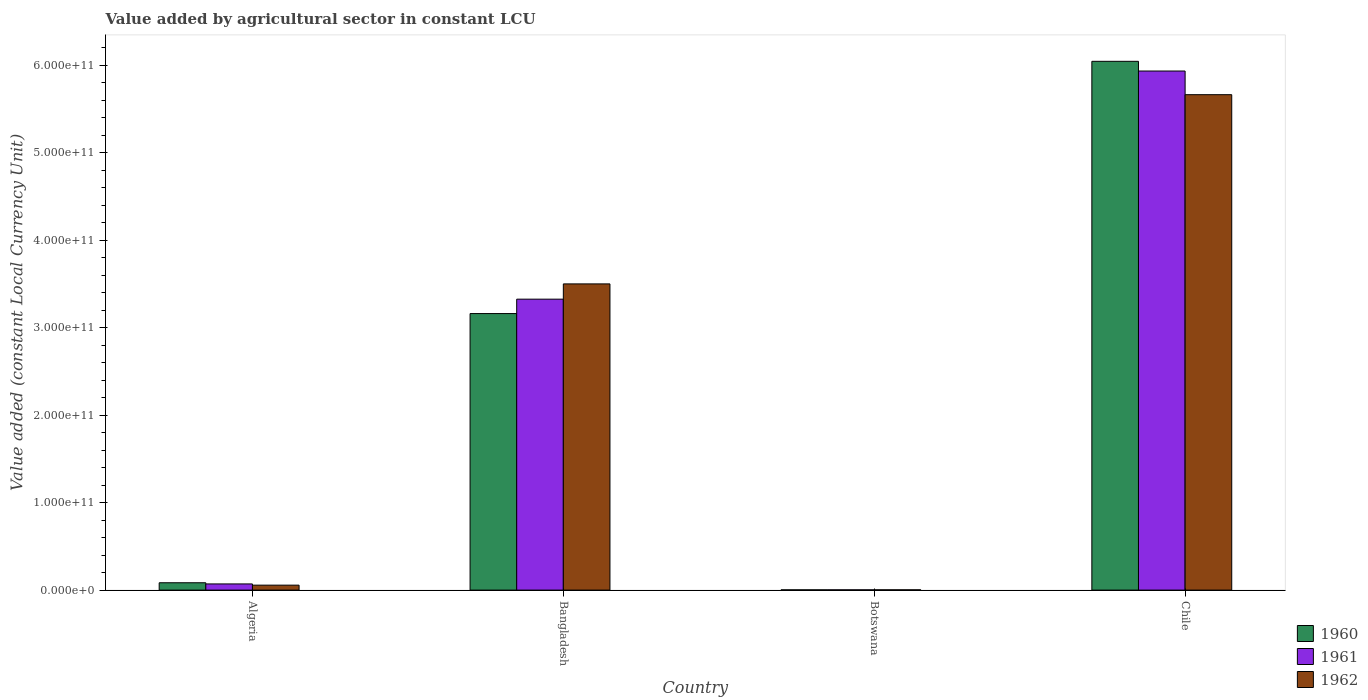How many different coloured bars are there?
Offer a terse response. 3. How many bars are there on the 4th tick from the right?
Offer a very short reply. 3. What is the label of the 3rd group of bars from the left?
Ensure brevity in your answer.  Botswana. What is the value added by agricultural sector in 1962 in Algeria?
Make the answer very short. 5.66e+09. Across all countries, what is the maximum value added by agricultural sector in 1961?
Offer a very short reply. 5.94e+11. Across all countries, what is the minimum value added by agricultural sector in 1960?
Your answer should be compact. 2.79e+08. In which country was the value added by agricultural sector in 1961 maximum?
Keep it short and to the point. Chile. In which country was the value added by agricultural sector in 1961 minimum?
Offer a very short reply. Botswana. What is the total value added by agricultural sector in 1962 in the graph?
Offer a very short reply. 9.23e+11. What is the difference between the value added by agricultural sector in 1960 in Botswana and that in Chile?
Provide a short and direct response. -6.04e+11. What is the difference between the value added by agricultural sector in 1961 in Chile and the value added by agricultural sector in 1962 in Bangladesh?
Give a very brief answer. 2.43e+11. What is the average value added by agricultural sector in 1962 per country?
Your answer should be compact. 2.31e+11. What is the difference between the value added by agricultural sector of/in 1960 and value added by agricultural sector of/in 1962 in Chile?
Your response must be concise. 3.82e+1. What is the ratio of the value added by agricultural sector in 1962 in Bangladesh to that in Chile?
Your response must be concise. 0.62. Is the difference between the value added by agricultural sector in 1960 in Botswana and Chile greater than the difference between the value added by agricultural sector in 1962 in Botswana and Chile?
Offer a terse response. No. What is the difference between the highest and the second highest value added by agricultural sector in 1961?
Offer a very short reply. 5.87e+11. What is the difference between the highest and the lowest value added by agricultural sector in 1960?
Your response must be concise. 6.04e+11. In how many countries, is the value added by agricultural sector in 1962 greater than the average value added by agricultural sector in 1962 taken over all countries?
Ensure brevity in your answer.  2. Is it the case that in every country, the sum of the value added by agricultural sector in 1960 and value added by agricultural sector in 1961 is greater than the value added by agricultural sector in 1962?
Give a very brief answer. Yes. Are all the bars in the graph horizontal?
Ensure brevity in your answer.  No. How many countries are there in the graph?
Provide a succinct answer. 4. What is the difference between two consecutive major ticks on the Y-axis?
Ensure brevity in your answer.  1.00e+11. Are the values on the major ticks of Y-axis written in scientific E-notation?
Your answer should be very brief. Yes. Does the graph contain grids?
Offer a terse response. No. How many legend labels are there?
Provide a short and direct response. 3. What is the title of the graph?
Your answer should be compact. Value added by agricultural sector in constant LCU. Does "1986" appear as one of the legend labels in the graph?
Provide a succinct answer. No. What is the label or title of the Y-axis?
Provide a succinct answer. Value added (constant Local Currency Unit). What is the Value added (constant Local Currency Unit) in 1960 in Algeria?
Offer a terse response. 8.40e+09. What is the Value added (constant Local Currency Unit) of 1961 in Algeria?
Give a very brief answer. 7.05e+09. What is the Value added (constant Local Currency Unit) in 1962 in Algeria?
Make the answer very short. 5.66e+09. What is the Value added (constant Local Currency Unit) in 1960 in Bangladesh?
Provide a short and direct response. 3.16e+11. What is the Value added (constant Local Currency Unit) in 1961 in Bangladesh?
Your response must be concise. 3.33e+11. What is the Value added (constant Local Currency Unit) of 1962 in Bangladesh?
Your answer should be very brief. 3.50e+11. What is the Value added (constant Local Currency Unit) of 1960 in Botswana?
Provide a short and direct response. 2.79e+08. What is the Value added (constant Local Currency Unit) of 1961 in Botswana?
Your answer should be very brief. 2.86e+08. What is the Value added (constant Local Currency Unit) in 1962 in Botswana?
Ensure brevity in your answer.  2.96e+08. What is the Value added (constant Local Currency Unit) of 1960 in Chile?
Provide a short and direct response. 6.05e+11. What is the Value added (constant Local Currency Unit) in 1961 in Chile?
Give a very brief answer. 5.94e+11. What is the Value added (constant Local Currency Unit) of 1962 in Chile?
Offer a terse response. 5.67e+11. Across all countries, what is the maximum Value added (constant Local Currency Unit) in 1960?
Your response must be concise. 6.05e+11. Across all countries, what is the maximum Value added (constant Local Currency Unit) in 1961?
Keep it short and to the point. 5.94e+11. Across all countries, what is the maximum Value added (constant Local Currency Unit) of 1962?
Your answer should be very brief. 5.67e+11. Across all countries, what is the minimum Value added (constant Local Currency Unit) of 1960?
Provide a succinct answer. 2.79e+08. Across all countries, what is the minimum Value added (constant Local Currency Unit) in 1961?
Your answer should be compact. 2.86e+08. Across all countries, what is the minimum Value added (constant Local Currency Unit) of 1962?
Ensure brevity in your answer.  2.96e+08. What is the total Value added (constant Local Currency Unit) of 1960 in the graph?
Provide a short and direct response. 9.30e+11. What is the total Value added (constant Local Currency Unit) in 1961 in the graph?
Your answer should be very brief. 9.34e+11. What is the total Value added (constant Local Currency Unit) in 1962 in the graph?
Your answer should be compact. 9.23e+11. What is the difference between the Value added (constant Local Currency Unit) in 1960 in Algeria and that in Bangladesh?
Make the answer very short. -3.08e+11. What is the difference between the Value added (constant Local Currency Unit) in 1961 in Algeria and that in Bangladesh?
Keep it short and to the point. -3.26e+11. What is the difference between the Value added (constant Local Currency Unit) in 1962 in Algeria and that in Bangladesh?
Provide a succinct answer. -3.44e+11. What is the difference between the Value added (constant Local Currency Unit) of 1960 in Algeria and that in Botswana?
Your answer should be very brief. 8.12e+09. What is the difference between the Value added (constant Local Currency Unit) in 1961 in Algeria and that in Botswana?
Provide a short and direct response. 6.77e+09. What is the difference between the Value added (constant Local Currency Unit) of 1962 in Algeria and that in Botswana?
Keep it short and to the point. 5.36e+09. What is the difference between the Value added (constant Local Currency Unit) of 1960 in Algeria and that in Chile?
Your response must be concise. -5.96e+11. What is the difference between the Value added (constant Local Currency Unit) in 1961 in Algeria and that in Chile?
Offer a very short reply. -5.87e+11. What is the difference between the Value added (constant Local Currency Unit) of 1962 in Algeria and that in Chile?
Make the answer very short. -5.61e+11. What is the difference between the Value added (constant Local Currency Unit) in 1960 in Bangladesh and that in Botswana?
Give a very brief answer. 3.16e+11. What is the difference between the Value added (constant Local Currency Unit) in 1961 in Bangladesh and that in Botswana?
Your answer should be very brief. 3.32e+11. What is the difference between the Value added (constant Local Currency Unit) in 1962 in Bangladesh and that in Botswana?
Give a very brief answer. 3.50e+11. What is the difference between the Value added (constant Local Currency Unit) in 1960 in Bangladesh and that in Chile?
Make the answer very short. -2.88e+11. What is the difference between the Value added (constant Local Currency Unit) of 1961 in Bangladesh and that in Chile?
Provide a succinct answer. -2.61e+11. What is the difference between the Value added (constant Local Currency Unit) in 1962 in Bangladesh and that in Chile?
Provide a short and direct response. -2.16e+11. What is the difference between the Value added (constant Local Currency Unit) of 1960 in Botswana and that in Chile?
Offer a very short reply. -6.04e+11. What is the difference between the Value added (constant Local Currency Unit) of 1961 in Botswana and that in Chile?
Offer a very short reply. -5.93e+11. What is the difference between the Value added (constant Local Currency Unit) of 1962 in Botswana and that in Chile?
Provide a succinct answer. -5.66e+11. What is the difference between the Value added (constant Local Currency Unit) in 1960 in Algeria and the Value added (constant Local Currency Unit) in 1961 in Bangladesh?
Keep it short and to the point. -3.24e+11. What is the difference between the Value added (constant Local Currency Unit) in 1960 in Algeria and the Value added (constant Local Currency Unit) in 1962 in Bangladesh?
Offer a terse response. -3.42e+11. What is the difference between the Value added (constant Local Currency Unit) of 1961 in Algeria and the Value added (constant Local Currency Unit) of 1962 in Bangladesh?
Your response must be concise. -3.43e+11. What is the difference between the Value added (constant Local Currency Unit) of 1960 in Algeria and the Value added (constant Local Currency Unit) of 1961 in Botswana?
Ensure brevity in your answer.  8.11e+09. What is the difference between the Value added (constant Local Currency Unit) of 1960 in Algeria and the Value added (constant Local Currency Unit) of 1962 in Botswana?
Your answer should be very brief. 8.10e+09. What is the difference between the Value added (constant Local Currency Unit) of 1961 in Algeria and the Value added (constant Local Currency Unit) of 1962 in Botswana?
Give a very brief answer. 6.76e+09. What is the difference between the Value added (constant Local Currency Unit) in 1960 in Algeria and the Value added (constant Local Currency Unit) in 1961 in Chile?
Offer a very short reply. -5.85e+11. What is the difference between the Value added (constant Local Currency Unit) in 1960 in Algeria and the Value added (constant Local Currency Unit) in 1962 in Chile?
Ensure brevity in your answer.  -5.58e+11. What is the difference between the Value added (constant Local Currency Unit) in 1961 in Algeria and the Value added (constant Local Currency Unit) in 1962 in Chile?
Give a very brief answer. -5.59e+11. What is the difference between the Value added (constant Local Currency Unit) of 1960 in Bangladesh and the Value added (constant Local Currency Unit) of 1961 in Botswana?
Give a very brief answer. 3.16e+11. What is the difference between the Value added (constant Local Currency Unit) of 1960 in Bangladesh and the Value added (constant Local Currency Unit) of 1962 in Botswana?
Your response must be concise. 3.16e+11. What is the difference between the Value added (constant Local Currency Unit) of 1961 in Bangladesh and the Value added (constant Local Currency Unit) of 1962 in Botswana?
Your response must be concise. 3.32e+11. What is the difference between the Value added (constant Local Currency Unit) of 1960 in Bangladesh and the Value added (constant Local Currency Unit) of 1961 in Chile?
Make the answer very short. -2.77e+11. What is the difference between the Value added (constant Local Currency Unit) of 1960 in Bangladesh and the Value added (constant Local Currency Unit) of 1962 in Chile?
Offer a terse response. -2.50e+11. What is the difference between the Value added (constant Local Currency Unit) in 1961 in Bangladesh and the Value added (constant Local Currency Unit) in 1962 in Chile?
Provide a succinct answer. -2.34e+11. What is the difference between the Value added (constant Local Currency Unit) in 1960 in Botswana and the Value added (constant Local Currency Unit) in 1961 in Chile?
Keep it short and to the point. -5.93e+11. What is the difference between the Value added (constant Local Currency Unit) in 1960 in Botswana and the Value added (constant Local Currency Unit) in 1962 in Chile?
Provide a succinct answer. -5.66e+11. What is the difference between the Value added (constant Local Currency Unit) in 1961 in Botswana and the Value added (constant Local Currency Unit) in 1962 in Chile?
Your answer should be compact. -5.66e+11. What is the average Value added (constant Local Currency Unit) in 1960 per country?
Offer a very short reply. 2.32e+11. What is the average Value added (constant Local Currency Unit) of 1961 per country?
Your response must be concise. 2.33e+11. What is the average Value added (constant Local Currency Unit) in 1962 per country?
Ensure brevity in your answer.  2.31e+11. What is the difference between the Value added (constant Local Currency Unit) in 1960 and Value added (constant Local Currency Unit) in 1961 in Algeria?
Your answer should be very brief. 1.35e+09. What is the difference between the Value added (constant Local Currency Unit) in 1960 and Value added (constant Local Currency Unit) in 1962 in Algeria?
Offer a very short reply. 2.74e+09. What is the difference between the Value added (constant Local Currency Unit) in 1961 and Value added (constant Local Currency Unit) in 1962 in Algeria?
Your answer should be very brief. 1.40e+09. What is the difference between the Value added (constant Local Currency Unit) in 1960 and Value added (constant Local Currency Unit) in 1961 in Bangladesh?
Provide a succinct answer. -1.65e+1. What is the difference between the Value added (constant Local Currency Unit) of 1960 and Value added (constant Local Currency Unit) of 1962 in Bangladesh?
Your answer should be compact. -3.39e+1. What is the difference between the Value added (constant Local Currency Unit) in 1961 and Value added (constant Local Currency Unit) in 1962 in Bangladesh?
Provide a succinct answer. -1.75e+1. What is the difference between the Value added (constant Local Currency Unit) of 1960 and Value added (constant Local Currency Unit) of 1961 in Botswana?
Your answer should be compact. -6.88e+06. What is the difference between the Value added (constant Local Currency Unit) of 1960 and Value added (constant Local Currency Unit) of 1962 in Botswana?
Offer a terse response. -1.72e+07. What is the difference between the Value added (constant Local Currency Unit) in 1961 and Value added (constant Local Currency Unit) in 1962 in Botswana?
Give a very brief answer. -1.03e+07. What is the difference between the Value added (constant Local Currency Unit) in 1960 and Value added (constant Local Currency Unit) in 1961 in Chile?
Keep it short and to the point. 1.11e+1. What is the difference between the Value added (constant Local Currency Unit) of 1960 and Value added (constant Local Currency Unit) of 1962 in Chile?
Give a very brief answer. 3.82e+1. What is the difference between the Value added (constant Local Currency Unit) of 1961 and Value added (constant Local Currency Unit) of 1962 in Chile?
Offer a terse response. 2.70e+1. What is the ratio of the Value added (constant Local Currency Unit) of 1960 in Algeria to that in Bangladesh?
Your answer should be very brief. 0.03. What is the ratio of the Value added (constant Local Currency Unit) in 1961 in Algeria to that in Bangladesh?
Make the answer very short. 0.02. What is the ratio of the Value added (constant Local Currency Unit) of 1962 in Algeria to that in Bangladesh?
Offer a very short reply. 0.02. What is the ratio of the Value added (constant Local Currency Unit) in 1960 in Algeria to that in Botswana?
Keep it short and to the point. 30.08. What is the ratio of the Value added (constant Local Currency Unit) in 1961 in Algeria to that in Botswana?
Offer a very short reply. 24.65. What is the ratio of the Value added (constant Local Currency Unit) of 1962 in Algeria to that in Botswana?
Give a very brief answer. 19.09. What is the ratio of the Value added (constant Local Currency Unit) of 1960 in Algeria to that in Chile?
Your answer should be very brief. 0.01. What is the ratio of the Value added (constant Local Currency Unit) in 1961 in Algeria to that in Chile?
Keep it short and to the point. 0.01. What is the ratio of the Value added (constant Local Currency Unit) in 1962 in Algeria to that in Chile?
Provide a succinct answer. 0.01. What is the ratio of the Value added (constant Local Currency Unit) in 1960 in Bangladesh to that in Botswana?
Ensure brevity in your answer.  1132.8. What is the ratio of the Value added (constant Local Currency Unit) in 1961 in Bangladesh to that in Botswana?
Offer a terse response. 1163.15. What is the ratio of the Value added (constant Local Currency Unit) in 1962 in Bangladesh to that in Botswana?
Offer a terse response. 1181.56. What is the ratio of the Value added (constant Local Currency Unit) in 1960 in Bangladesh to that in Chile?
Your answer should be compact. 0.52. What is the ratio of the Value added (constant Local Currency Unit) of 1961 in Bangladesh to that in Chile?
Your answer should be compact. 0.56. What is the ratio of the Value added (constant Local Currency Unit) of 1962 in Bangladesh to that in Chile?
Give a very brief answer. 0.62. What is the ratio of the Value added (constant Local Currency Unit) in 1960 in Botswana to that in Chile?
Provide a succinct answer. 0. What is the difference between the highest and the second highest Value added (constant Local Currency Unit) in 1960?
Keep it short and to the point. 2.88e+11. What is the difference between the highest and the second highest Value added (constant Local Currency Unit) in 1961?
Offer a terse response. 2.61e+11. What is the difference between the highest and the second highest Value added (constant Local Currency Unit) in 1962?
Provide a short and direct response. 2.16e+11. What is the difference between the highest and the lowest Value added (constant Local Currency Unit) of 1960?
Offer a terse response. 6.04e+11. What is the difference between the highest and the lowest Value added (constant Local Currency Unit) of 1961?
Your response must be concise. 5.93e+11. What is the difference between the highest and the lowest Value added (constant Local Currency Unit) in 1962?
Give a very brief answer. 5.66e+11. 